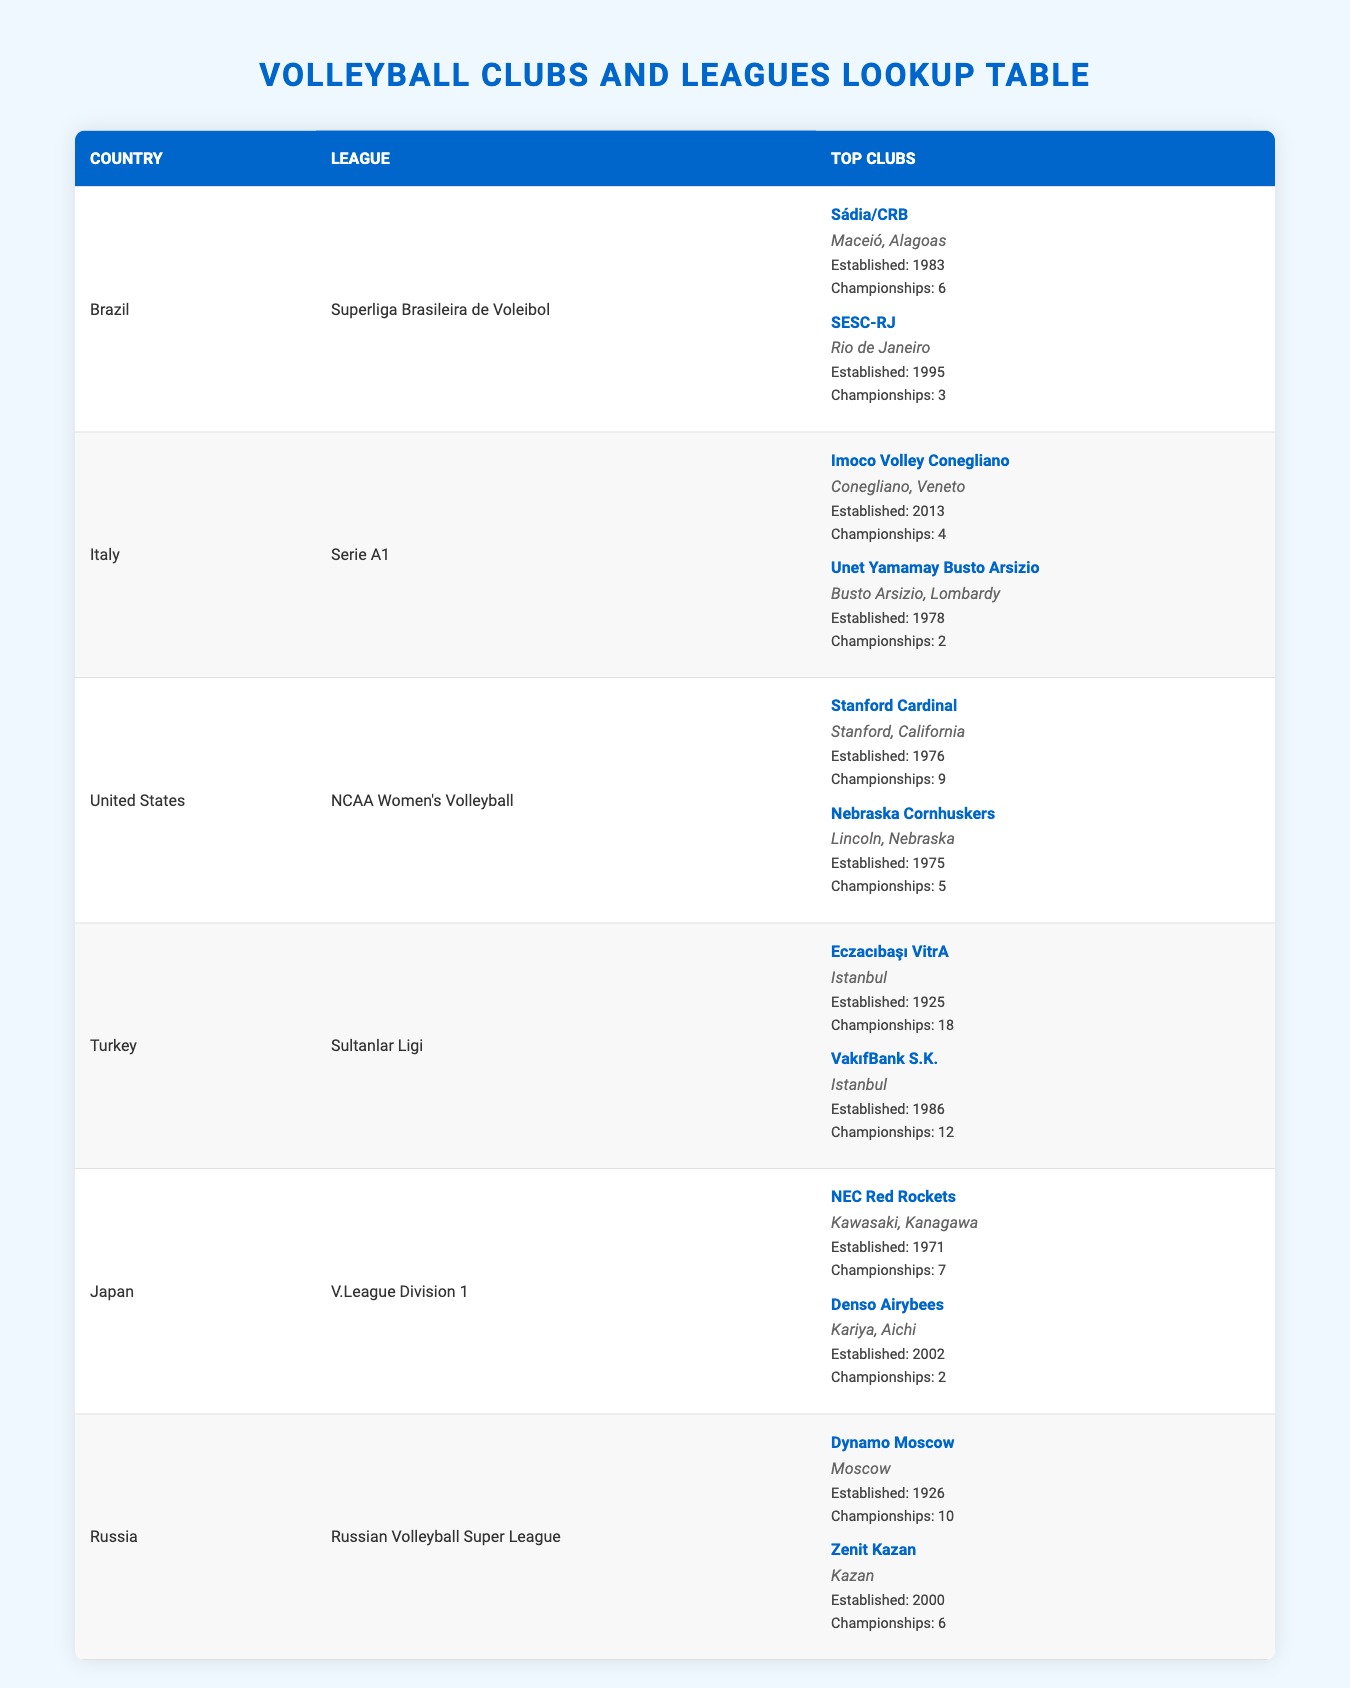What is the league for clubs in Italy? The league for clubs in Italy is listed in the second row of the table under the "League" column as "Serie A1."
Answer: Serie A1 Which club in the United States has the most championships? By checking the "Championships" column for the clubs listed under the United States, Stanford Cardinal has won 9 championships, which is more than the Nebraska Cornhuskers' 5 championships.
Answer: Stanford Cardinal How many championships has Eczacıbaşı VitrA won? Looking at the Turkish league entry in the table, Eczacıbaşı VitrA is listed with 18 championships in the "Championships" section.
Answer: 18 Is it true that the club named Zenit Kazan is established before 2000? The table shows that Zenit Kazan was established in 2000, which means it cannot be established before that year.
Answer: No What is the average number of championships won by top clubs in Japan? The clubs in Japan listed are NEC Red Rockets (7 championships) and Denso Airybees (2 championships). The sum of the championships is 7 + 2 = 9. There are 2 clubs, so the average is 9 / 2 = 4.5.
Answer: 4.5 Which country has the club with the highest number of championships? Comparing the championships won by the top clubs across all countries listed, Eczacıbaşı VitrA from Turkey has 18 championships, which is the highest compared to other clubs like Stanford Cardinal, which has 9.
Answer: Turkey How many clubs from Brazil have won more than 5 championships? In the Brazilian league, Sádia/CRB has won 6 championships, which is more than 5, while SESC-RJ has won 3, which is less than or equal to 5. Therefore, only one club has won more than 5 championships.
Answer: 1 Which club has been established earlier: Unet Yamamay Busto Arsizio or SESC-RJ? Checking the "Established" column for these two clubs, Unet Yamamay Busto Arsizio was established in 1978 and SESC-RJ was established in 1995. Since 1978 is earlier than 1995, Unet Yamamay Busto Arsizio is the correct answer.
Answer: Unet Yamamay Busto Arsizio Are there more clubs in Brazil or in Turkey based on the table? The table shows that both Brazil and Turkey have two clubs listed. Therefore, neither country has more clubs than the other; they are equal.
Answer: No 